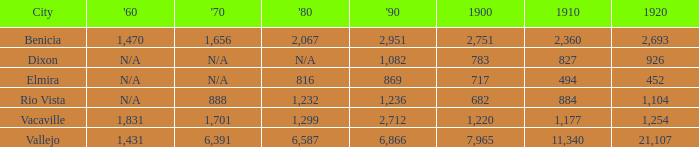What is the 1920 number when 1890 is greater than 1,236, 1910 is less than 1,177 and the city is Vacaville? None. 